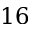Convert formula to latex. <formula><loc_0><loc_0><loc_500><loc_500>1 6</formula> 